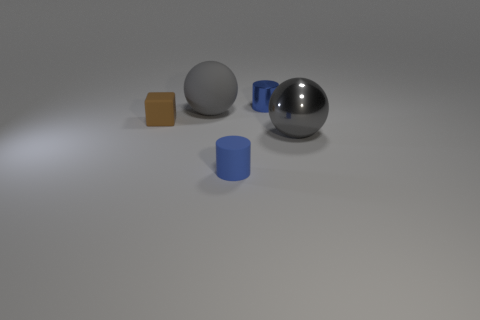There is a rubber thing in front of the small brown object; what shape is it?
Provide a succinct answer. Cylinder. The matte ball is what color?
Provide a succinct answer. Gray. There is a blue object that is made of the same material as the tiny brown block; what shape is it?
Ensure brevity in your answer.  Cylinder. Does the sphere to the right of the blue rubber thing have the same size as the large rubber object?
Provide a short and direct response. Yes. How many things are tiny things behind the matte cube or gray spheres behind the small brown cube?
Offer a terse response. 2. There is a big ball that is right of the small blue matte object; is its color the same as the small metallic cylinder?
Provide a succinct answer. No. How many matte objects are either cylinders or gray cylinders?
Offer a terse response. 1. What shape is the blue metal thing?
Your answer should be very brief. Cylinder. Is there anything else that has the same material as the tiny brown thing?
Ensure brevity in your answer.  Yes. Are there any tiny metallic cylinders that are left of the cube in front of the matte object behind the brown matte block?
Your answer should be compact. No. 